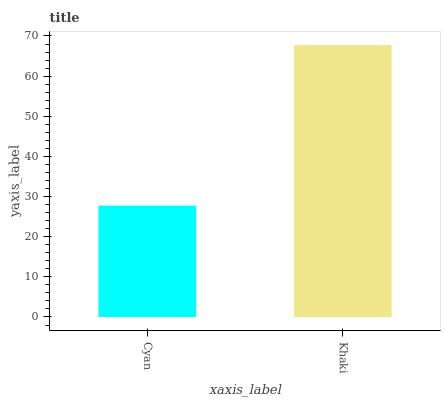Is Cyan the minimum?
Answer yes or no. Yes. Is Khaki the maximum?
Answer yes or no. Yes. Is Khaki the minimum?
Answer yes or no. No. Is Khaki greater than Cyan?
Answer yes or no. Yes. Is Cyan less than Khaki?
Answer yes or no. Yes. Is Cyan greater than Khaki?
Answer yes or no. No. Is Khaki less than Cyan?
Answer yes or no. No. Is Khaki the high median?
Answer yes or no. Yes. Is Cyan the low median?
Answer yes or no. Yes. Is Cyan the high median?
Answer yes or no. No. Is Khaki the low median?
Answer yes or no. No. 